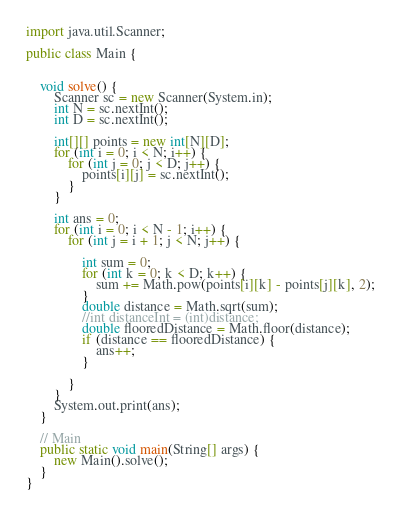<code> <loc_0><loc_0><loc_500><loc_500><_Java_>import java.util.Scanner;

public class Main {


    void solve() {
        Scanner sc = new Scanner(System.in);
        int N = sc.nextInt();
        int D = sc.nextInt();

        int[][] points = new int[N][D];
        for (int i = 0; i < N; i++) {
            for (int j = 0; j < D; j++) {
                points[i][j] = sc.nextInt();
            }
        }

        int ans = 0;
        for (int i = 0; i < N - 1; i++) {
            for (int j = i + 1; j < N; j++) {

                int sum = 0;
                for (int k = 0; k < D; k++) {
                    sum += Math.pow(points[i][k] - points[j][k], 2);
                }
                double distance = Math.sqrt(sum);
                //int distanceInt = (int)distance;
                double flooredDistance = Math.floor(distance);
                if (distance == flooredDistance) {
                    ans++;
                }

            }
        }
        System.out.print(ans);
    }

    // Main
    public static void main(String[] args) {
        new Main().solve();
    }
}

</code> 